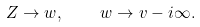Convert formula to latex. <formula><loc_0><loc_0><loc_500><loc_500>Z \to w , \quad w \to v - i \infty .</formula> 